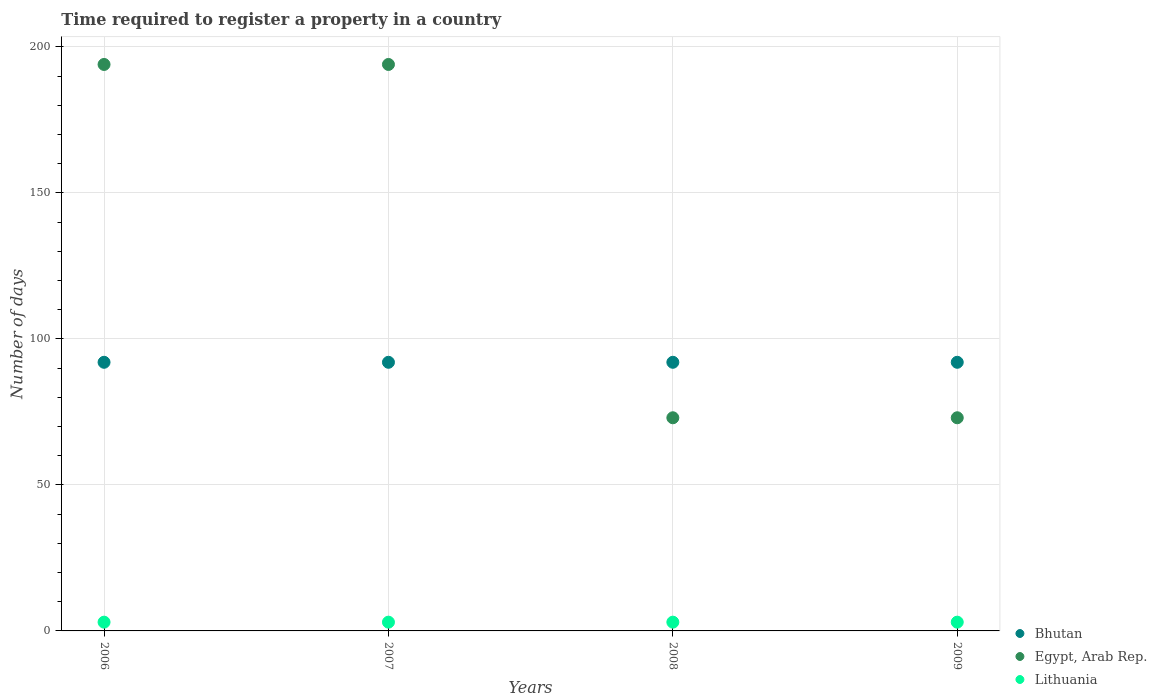Is the number of dotlines equal to the number of legend labels?
Provide a short and direct response. Yes. What is the number of days required to register a property in Lithuania in 2007?
Your response must be concise. 3. Across all years, what is the maximum number of days required to register a property in Lithuania?
Make the answer very short. 3. In which year was the number of days required to register a property in Lithuania minimum?
Your answer should be very brief. 2006. What is the total number of days required to register a property in Lithuania in the graph?
Provide a short and direct response. 12. What is the difference between the number of days required to register a property in Lithuania in 2008 and that in 2009?
Give a very brief answer. 0. What is the difference between the number of days required to register a property in Bhutan in 2007 and the number of days required to register a property in Egypt, Arab Rep. in 2008?
Give a very brief answer. 19. In the year 2007, what is the difference between the number of days required to register a property in Egypt, Arab Rep. and number of days required to register a property in Lithuania?
Offer a terse response. 191. In how many years, is the number of days required to register a property in Lithuania greater than 190 days?
Your answer should be compact. 0. Is the difference between the number of days required to register a property in Egypt, Arab Rep. in 2006 and 2009 greater than the difference between the number of days required to register a property in Lithuania in 2006 and 2009?
Offer a very short reply. Yes. What is the difference between the highest and the second highest number of days required to register a property in Lithuania?
Keep it short and to the point. 0. What is the difference between the highest and the lowest number of days required to register a property in Bhutan?
Your answer should be compact. 0. In how many years, is the number of days required to register a property in Egypt, Arab Rep. greater than the average number of days required to register a property in Egypt, Arab Rep. taken over all years?
Give a very brief answer. 2. Is the sum of the number of days required to register a property in Egypt, Arab Rep. in 2008 and 2009 greater than the maximum number of days required to register a property in Lithuania across all years?
Your answer should be very brief. Yes. Is the number of days required to register a property in Bhutan strictly less than the number of days required to register a property in Lithuania over the years?
Make the answer very short. No. Does the graph contain any zero values?
Make the answer very short. No. Does the graph contain grids?
Provide a succinct answer. Yes. Where does the legend appear in the graph?
Your response must be concise. Bottom right. How are the legend labels stacked?
Offer a very short reply. Vertical. What is the title of the graph?
Give a very brief answer. Time required to register a property in a country. Does "Swaziland" appear as one of the legend labels in the graph?
Provide a short and direct response. No. What is the label or title of the X-axis?
Make the answer very short. Years. What is the label or title of the Y-axis?
Your answer should be compact. Number of days. What is the Number of days of Bhutan in 2006?
Ensure brevity in your answer.  92. What is the Number of days in Egypt, Arab Rep. in 2006?
Your answer should be very brief. 194. What is the Number of days in Bhutan in 2007?
Your answer should be compact. 92. What is the Number of days of Egypt, Arab Rep. in 2007?
Provide a succinct answer. 194. What is the Number of days of Lithuania in 2007?
Provide a short and direct response. 3. What is the Number of days in Bhutan in 2008?
Offer a very short reply. 92. What is the Number of days in Bhutan in 2009?
Provide a short and direct response. 92. What is the Number of days in Lithuania in 2009?
Your response must be concise. 3. Across all years, what is the maximum Number of days in Bhutan?
Provide a short and direct response. 92. Across all years, what is the maximum Number of days of Egypt, Arab Rep.?
Offer a terse response. 194. Across all years, what is the minimum Number of days of Bhutan?
Ensure brevity in your answer.  92. Across all years, what is the minimum Number of days in Egypt, Arab Rep.?
Provide a short and direct response. 73. What is the total Number of days of Bhutan in the graph?
Give a very brief answer. 368. What is the total Number of days of Egypt, Arab Rep. in the graph?
Give a very brief answer. 534. What is the total Number of days in Lithuania in the graph?
Offer a terse response. 12. What is the difference between the Number of days of Bhutan in 2006 and that in 2007?
Provide a short and direct response. 0. What is the difference between the Number of days of Bhutan in 2006 and that in 2008?
Provide a short and direct response. 0. What is the difference between the Number of days in Egypt, Arab Rep. in 2006 and that in 2008?
Offer a very short reply. 121. What is the difference between the Number of days of Egypt, Arab Rep. in 2006 and that in 2009?
Provide a succinct answer. 121. What is the difference between the Number of days in Egypt, Arab Rep. in 2007 and that in 2008?
Offer a terse response. 121. What is the difference between the Number of days of Lithuania in 2007 and that in 2008?
Your response must be concise. 0. What is the difference between the Number of days of Egypt, Arab Rep. in 2007 and that in 2009?
Your answer should be very brief. 121. What is the difference between the Number of days in Lithuania in 2007 and that in 2009?
Offer a terse response. 0. What is the difference between the Number of days of Bhutan in 2006 and the Number of days of Egypt, Arab Rep. in 2007?
Provide a short and direct response. -102. What is the difference between the Number of days in Bhutan in 2006 and the Number of days in Lithuania in 2007?
Offer a very short reply. 89. What is the difference between the Number of days of Egypt, Arab Rep. in 2006 and the Number of days of Lithuania in 2007?
Provide a succinct answer. 191. What is the difference between the Number of days of Bhutan in 2006 and the Number of days of Lithuania in 2008?
Provide a succinct answer. 89. What is the difference between the Number of days in Egypt, Arab Rep. in 2006 and the Number of days in Lithuania in 2008?
Provide a short and direct response. 191. What is the difference between the Number of days of Bhutan in 2006 and the Number of days of Lithuania in 2009?
Offer a very short reply. 89. What is the difference between the Number of days in Egypt, Arab Rep. in 2006 and the Number of days in Lithuania in 2009?
Make the answer very short. 191. What is the difference between the Number of days of Bhutan in 2007 and the Number of days of Lithuania in 2008?
Ensure brevity in your answer.  89. What is the difference between the Number of days of Egypt, Arab Rep. in 2007 and the Number of days of Lithuania in 2008?
Your response must be concise. 191. What is the difference between the Number of days of Bhutan in 2007 and the Number of days of Egypt, Arab Rep. in 2009?
Your answer should be compact. 19. What is the difference between the Number of days in Bhutan in 2007 and the Number of days in Lithuania in 2009?
Your response must be concise. 89. What is the difference between the Number of days of Egypt, Arab Rep. in 2007 and the Number of days of Lithuania in 2009?
Ensure brevity in your answer.  191. What is the difference between the Number of days of Bhutan in 2008 and the Number of days of Lithuania in 2009?
Keep it short and to the point. 89. What is the average Number of days in Bhutan per year?
Offer a terse response. 92. What is the average Number of days in Egypt, Arab Rep. per year?
Offer a very short reply. 133.5. In the year 2006, what is the difference between the Number of days in Bhutan and Number of days in Egypt, Arab Rep.?
Your response must be concise. -102. In the year 2006, what is the difference between the Number of days in Bhutan and Number of days in Lithuania?
Your answer should be very brief. 89. In the year 2006, what is the difference between the Number of days of Egypt, Arab Rep. and Number of days of Lithuania?
Provide a short and direct response. 191. In the year 2007, what is the difference between the Number of days of Bhutan and Number of days of Egypt, Arab Rep.?
Make the answer very short. -102. In the year 2007, what is the difference between the Number of days of Bhutan and Number of days of Lithuania?
Give a very brief answer. 89. In the year 2007, what is the difference between the Number of days of Egypt, Arab Rep. and Number of days of Lithuania?
Keep it short and to the point. 191. In the year 2008, what is the difference between the Number of days in Bhutan and Number of days in Egypt, Arab Rep.?
Your response must be concise. 19. In the year 2008, what is the difference between the Number of days in Bhutan and Number of days in Lithuania?
Offer a very short reply. 89. In the year 2009, what is the difference between the Number of days of Bhutan and Number of days of Lithuania?
Give a very brief answer. 89. What is the ratio of the Number of days of Bhutan in 2006 to that in 2007?
Provide a succinct answer. 1. What is the ratio of the Number of days in Egypt, Arab Rep. in 2006 to that in 2008?
Your answer should be compact. 2.66. What is the ratio of the Number of days in Egypt, Arab Rep. in 2006 to that in 2009?
Ensure brevity in your answer.  2.66. What is the ratio of the Number of days in Lithuania in 2006 to that in 2009?
Your answer should be compact. 1. What is the ratio of the Number of days of Bhutan in 2007 to that in 2008?
Your answer should be very brief. 1. What is the ratio of the Number of days of Egypt, Arab Rep. in 2007 to that in 2008?
Provide a succinct answer. 2.66. What is the ratio of the Number of days of Lithuania in 2007 to that in 2008?
Your answer should be very brief. 1. What is the ratio of the Number of days in Bhutan in 2007 to that in 2009?
Your answer should be compact. 1. What is the ratio of the Number of days in Egypt, Arab Rep. in 2007 to that in 2009?
Ensure brevity in your answer.  2.66. What is the difference between the highest and the second highest Number of days in Egypt, Arab Rep.?
Provide a short and direct response. 0. What is the difference between the highest and the second highest Number of days of Lithuania?
Keep it short and to the point. 0. What is the difference between the highest and the lowest Number of days in Bhutan?
Provide a short and direct response. 0. What is the difference between the highest and the lowest Number of days of Egypt, Arab Rep.?
Ensure brevity in your answer.  121. 